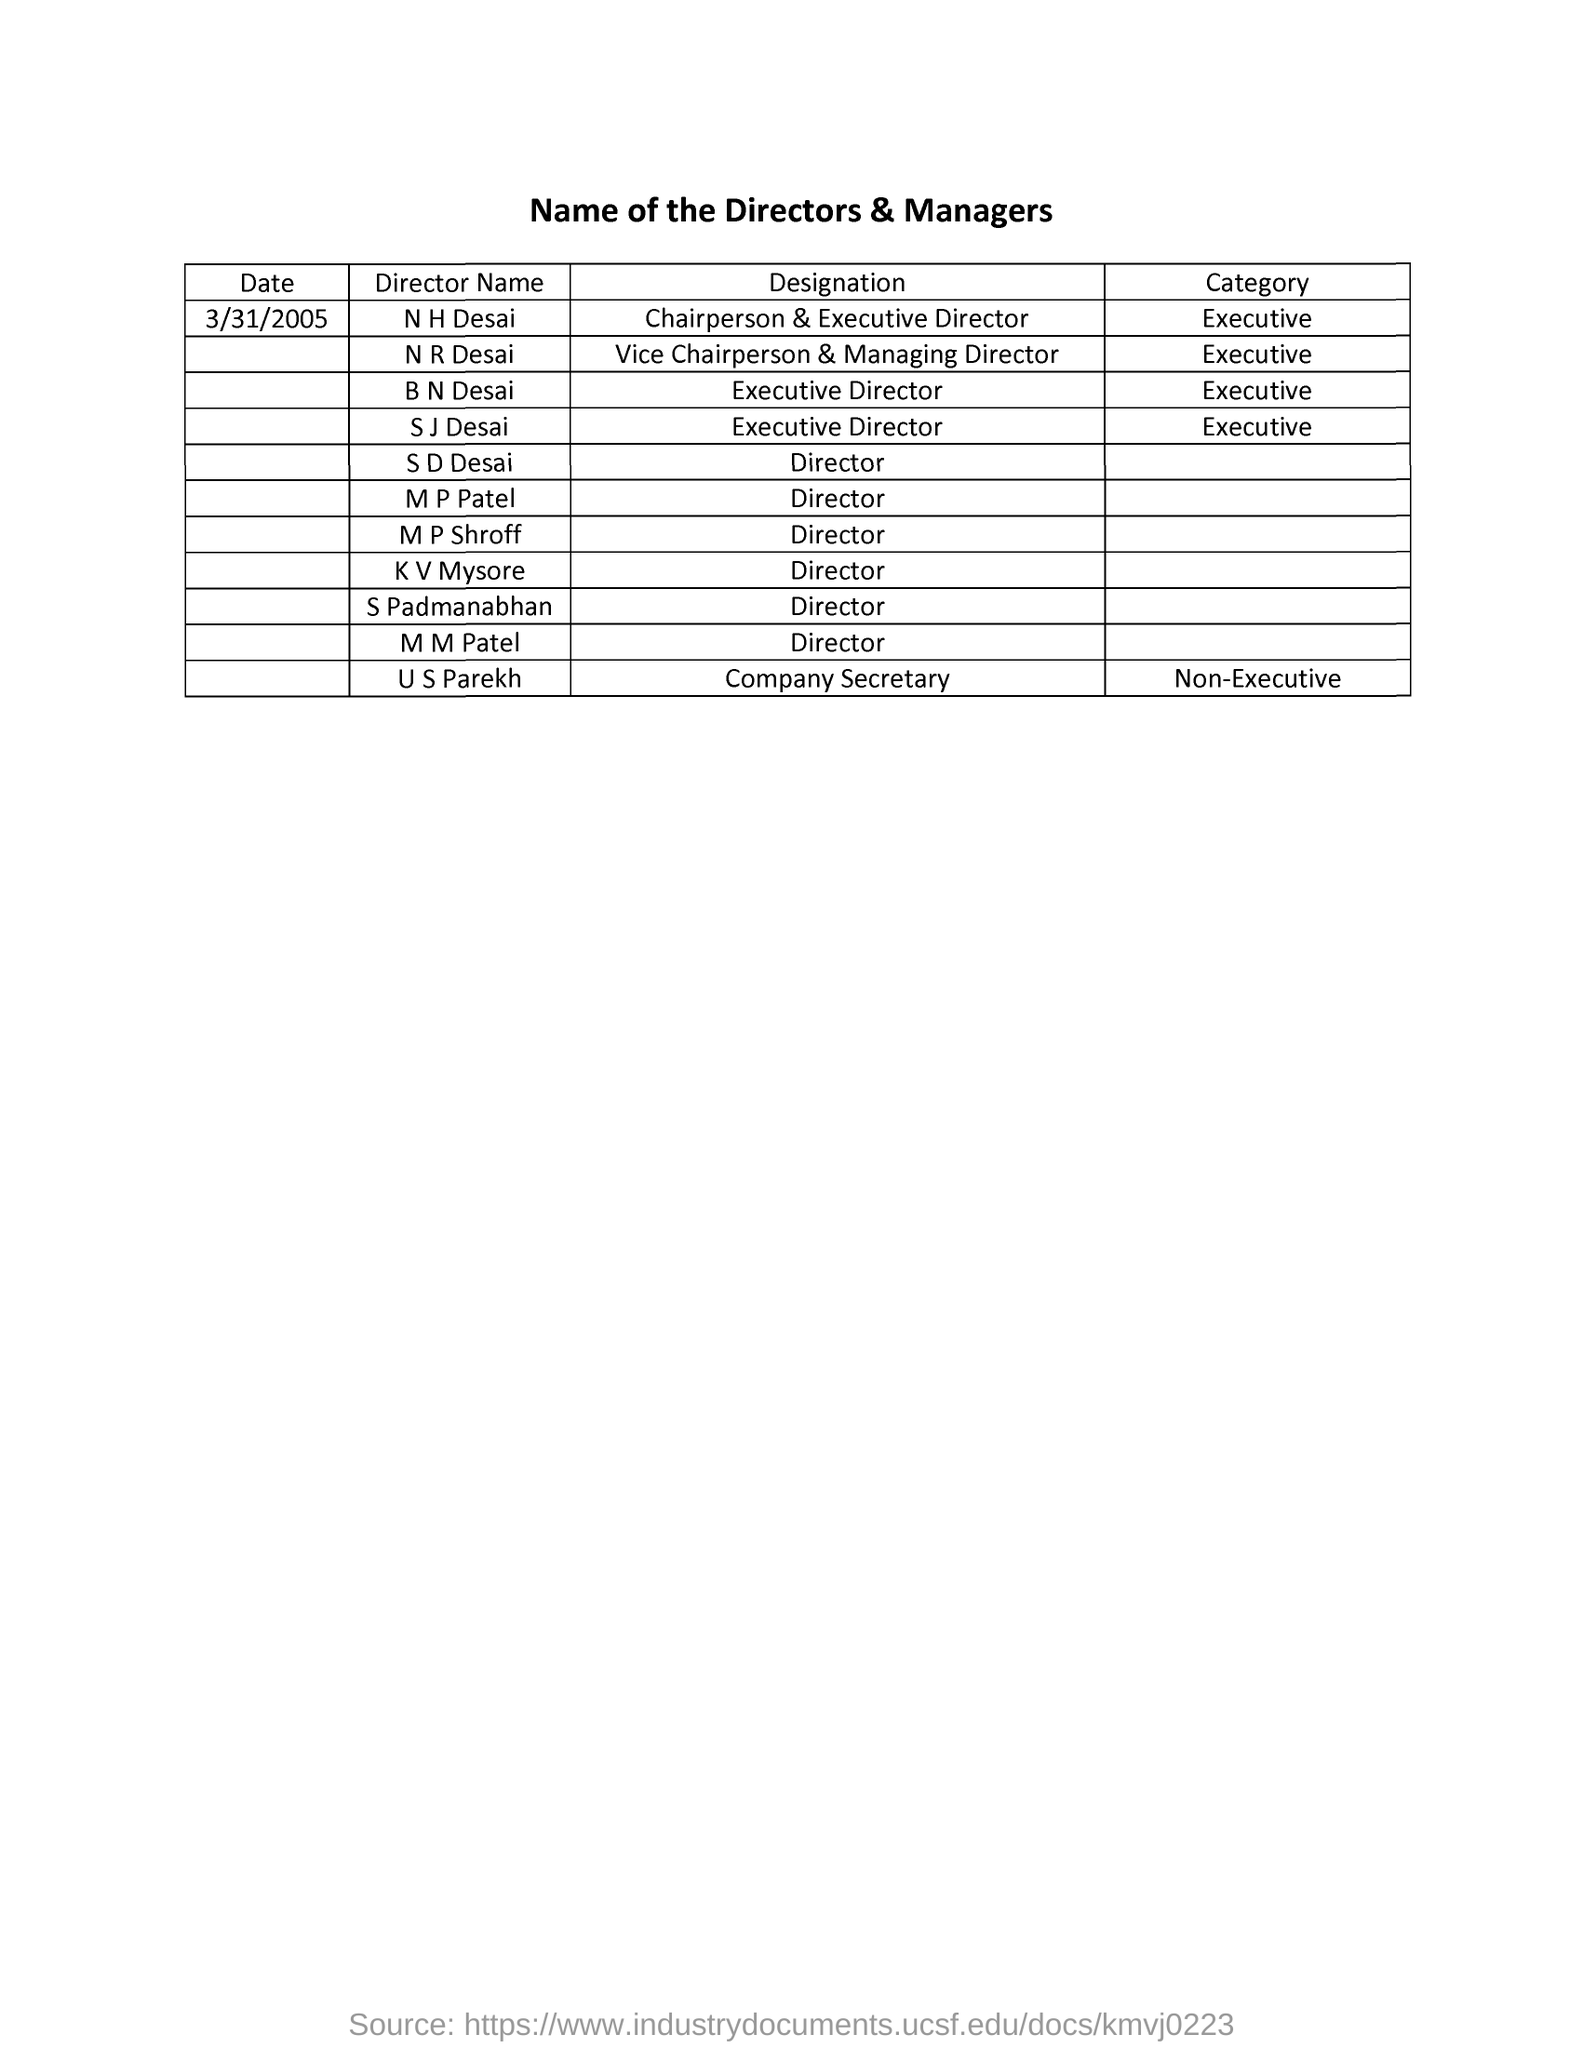What is the designation of n h desai ?
Your response must be concise. Chairperson & executive director. What is the category of n r desai ?
Keep it short and to the point. Executive. What is the date mentioned in the given page ?
Offer a terse response. 3/31/2005. To which category b n desai belongs to ?
Your answer should be compact. Executive. What is the designation of m p shroff ?
Keep it short and to the point. Director. What is the designation of u s parekh ?
Provide a short and direct response. Company Secretary. What is the category of u s parekh ?
Your response must be concise. Non-executive. What is the designation of s d desai ?
Make the answer very short. Director. What is the designation of n r desai ?
Provide a short and direct response. Vice Chairperson & Managing Director. 